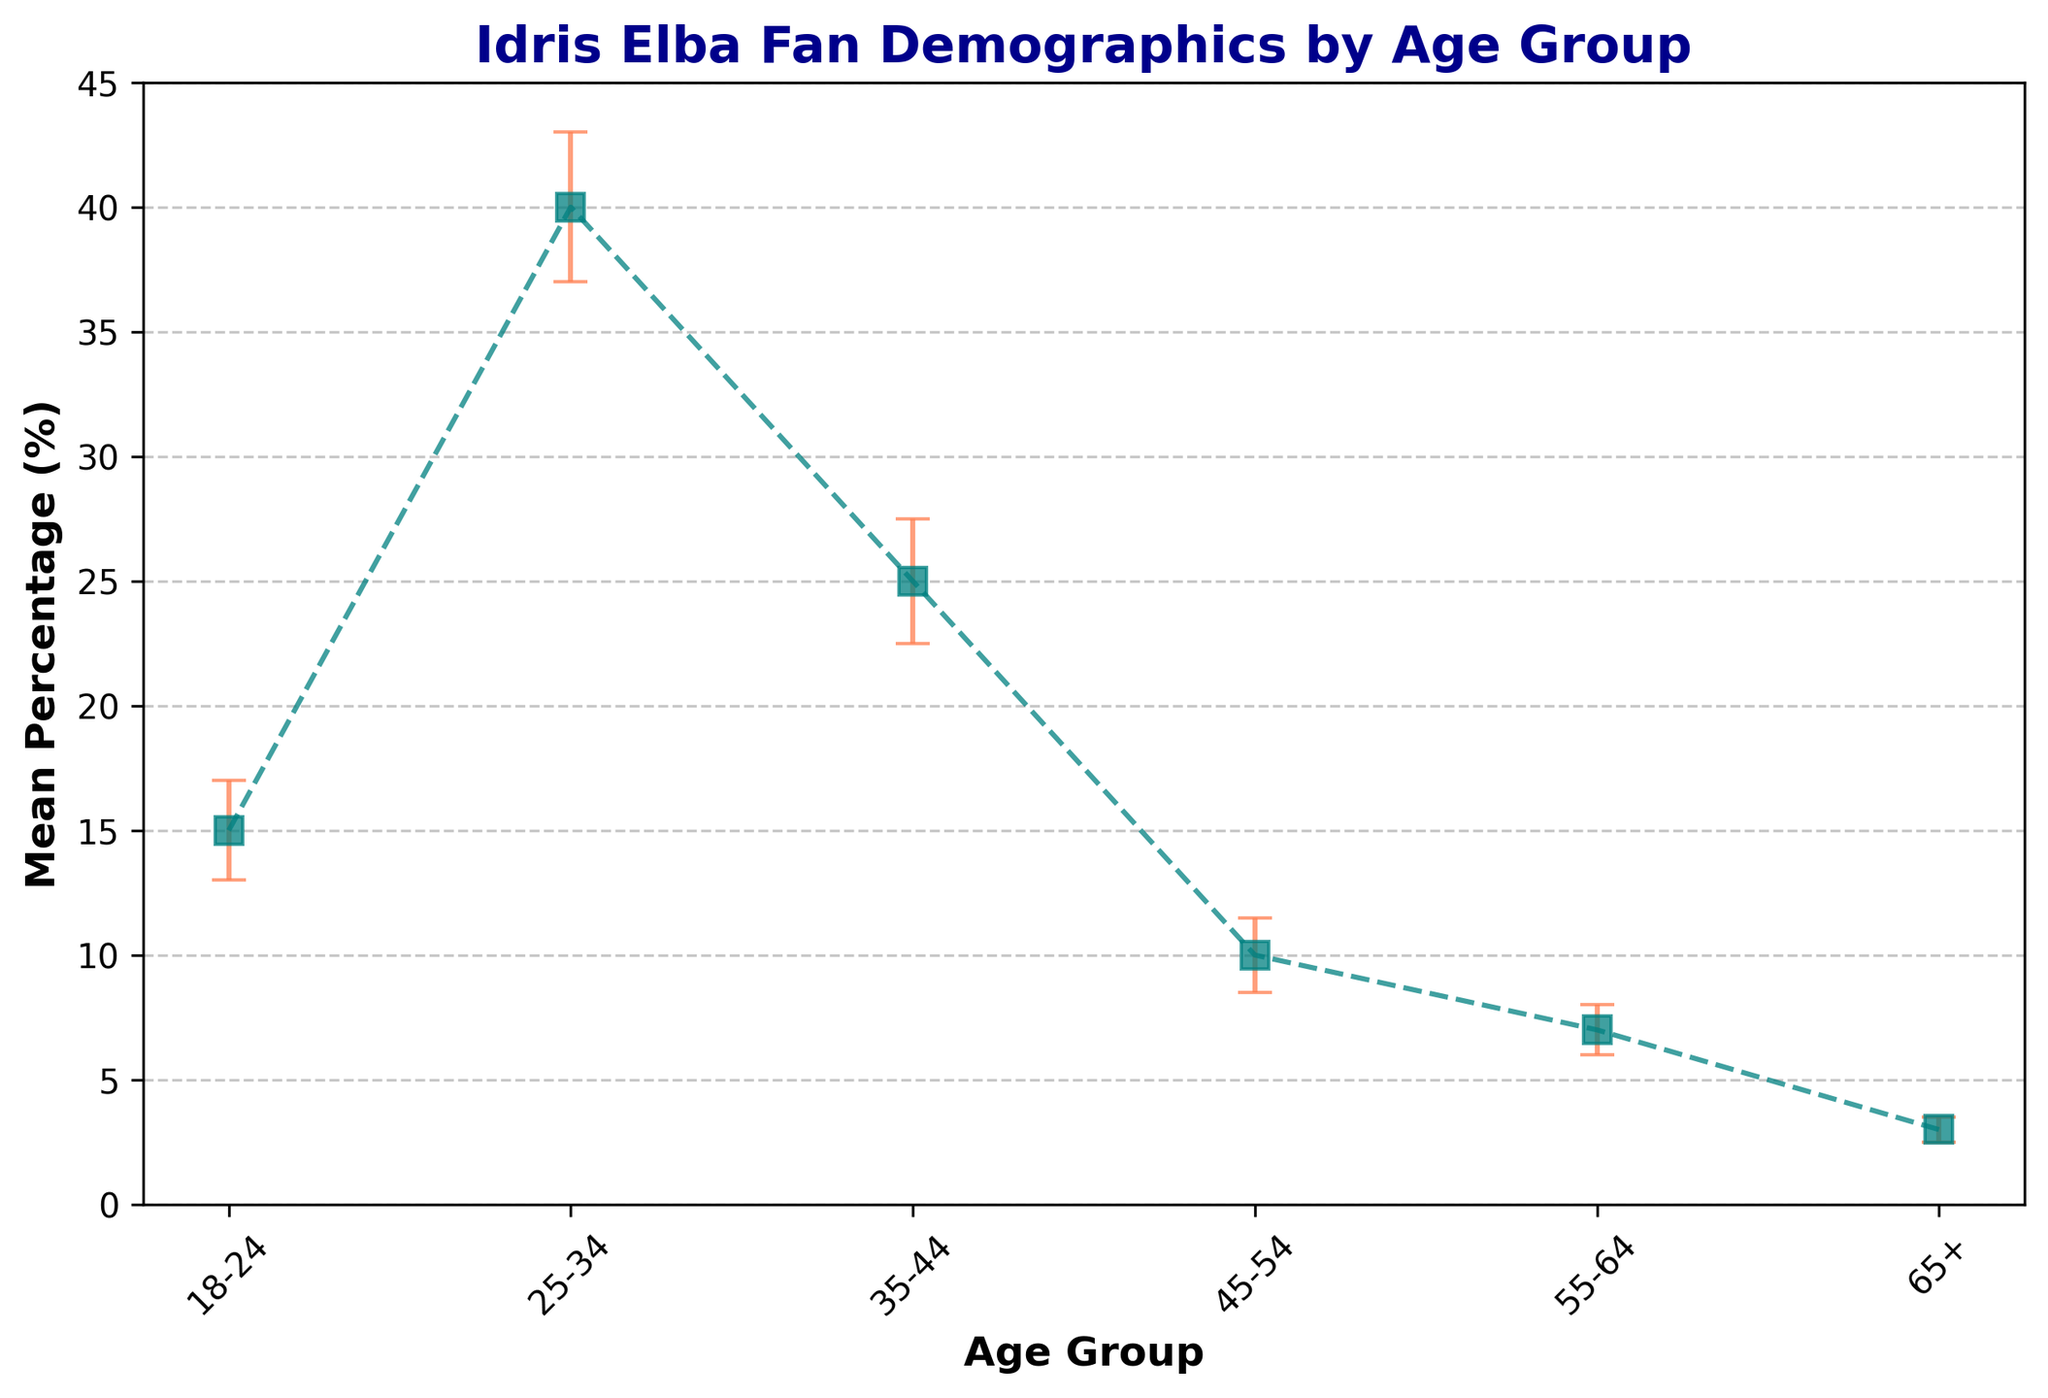Which age group has the highest percentage of Idris Elba fans? From the figure, the 25-34 age group has the highest mean percentage, as indicated by the highest point on the plot with error bars.
Answer: 25-34 How much higher is the percentage of fans in the 25-34 age group compared to the 45-54 age group? The 25-34 age group has a mean percentage of 40% while the 45-54 age group has 10%. Subtracting these, we find 40% - 10% = 30%.
Answer: 30% What is the sum of the mean percentages for age groups 35-44 and 55-64? The mean percentage for 35-44 is 25% and for 55-64 is 7%. Adding these together gives 25% + 7% = 32%.
Answer: 32% Which age group has the smallest fan percentage, and what is that percentage? The 65+ age group has the smallest mean percentage, indicated by the lowest point on the plot, which is 3%.
Answer: 65+, 3% What is the range of percentages for the 25-34 age group considering the standard error? The mean percentage for 25-34 is 40%, with a standard error of 3%. The range is from (40% - 3%) to (40% + 3%), so 37% to 43%.
Answer: 37%-43% Which two age groups have the closest mean percentages, and what are their percentages? The 18-24 age group has a mean percentage of 15%, and the 45-54 age group has 10%. The difference between these two percentages is the smallest gap compared to other age groups.
Answer: 18-24 (15%), 45-54 (10%) Is the percentage of fans in the 35-44 age group significantly different from the 18-24 age group considering the error bars? From the plot, the mean percentage for the 35-44 age group is 25% with an error of ±2.5%. The 18-24 age group has 15% ±2%. The intervals don't overlap (35-44: 22.5%-27.5%, 18-24: 13%-17%), indicating a significant difference.
Answer: Yes What is the average mean percentage of fans across all age groups? Adding the mean percentages for all age groups: 15% + 40% + 25% + 10% + 7% + 3% = 100%. Dividing by the number of age groups (6): 100% / 6 ≈ 16.67%.
Answer: 16.67% Which age group has the largest standard error, and what is the value? The 25-34 age group has the largest standard error, which is indicated by the size of the error bars on the plot, and the value is 3%.
Answer: 25-34, 3% Considering the standard errors, what is the combined range of potential percentages for the 18-24 and 35-44 age groups? For 18-24, the range is 15% ±2% (13%-17%). For 35-44, the range is 25% ±2.5% (22.5%-27.5%). Combining them, the overall potential range is from 13% to 27.5%.
Answer: 13%-27.5% 